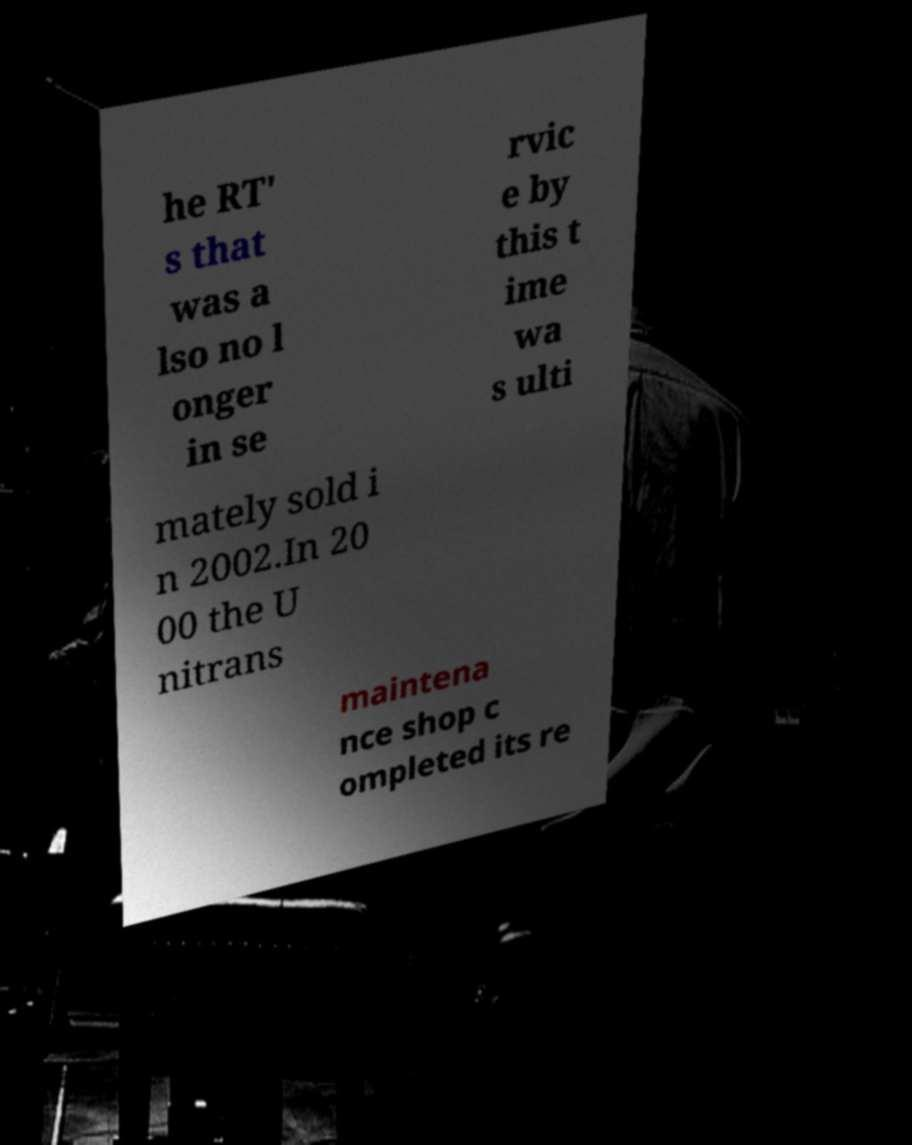Could you extract and type out the text from this image? he RT' s that was a lso no l onger in se rvic e by this t ime wa s ulti mately sold i n 2002.In 20 00 the U nitrans maintena nce shop c ompleted its re 